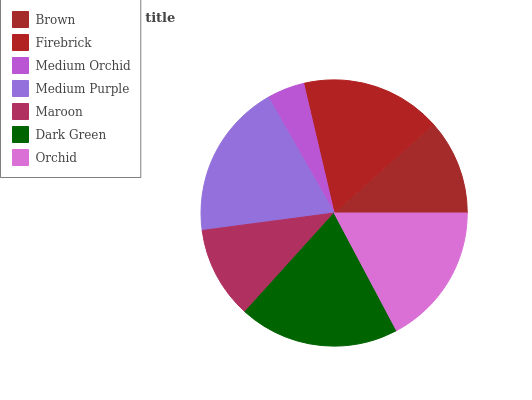Is Medium Orchid the minimum?
Answer yes or no. Yes. Is Dark Green the maximum?
Answer yes or no. Yes. Is Firebrick the minimum?
Answer yes or no. No. Is Firebrick the maximum?
Answer yes or no. No. Is Firebrick greater than Brown?
Answer yes or no. Yes. Is Brown less than Firebrick?
Answer yes or no. Yes. Is Brown greater than Firebrick?
Answer yes or no. No. Is Firebrick less than Brown?
Answer yes or no. No. Is Firebrick the high median?
Answer yes or no. Yes. Is Firebrick the low median?
Answer yes or no. Yes. Is Dark Green the high median?
Answer yes or no. No. Is Brown the low median?
Answer yes or no. No. 